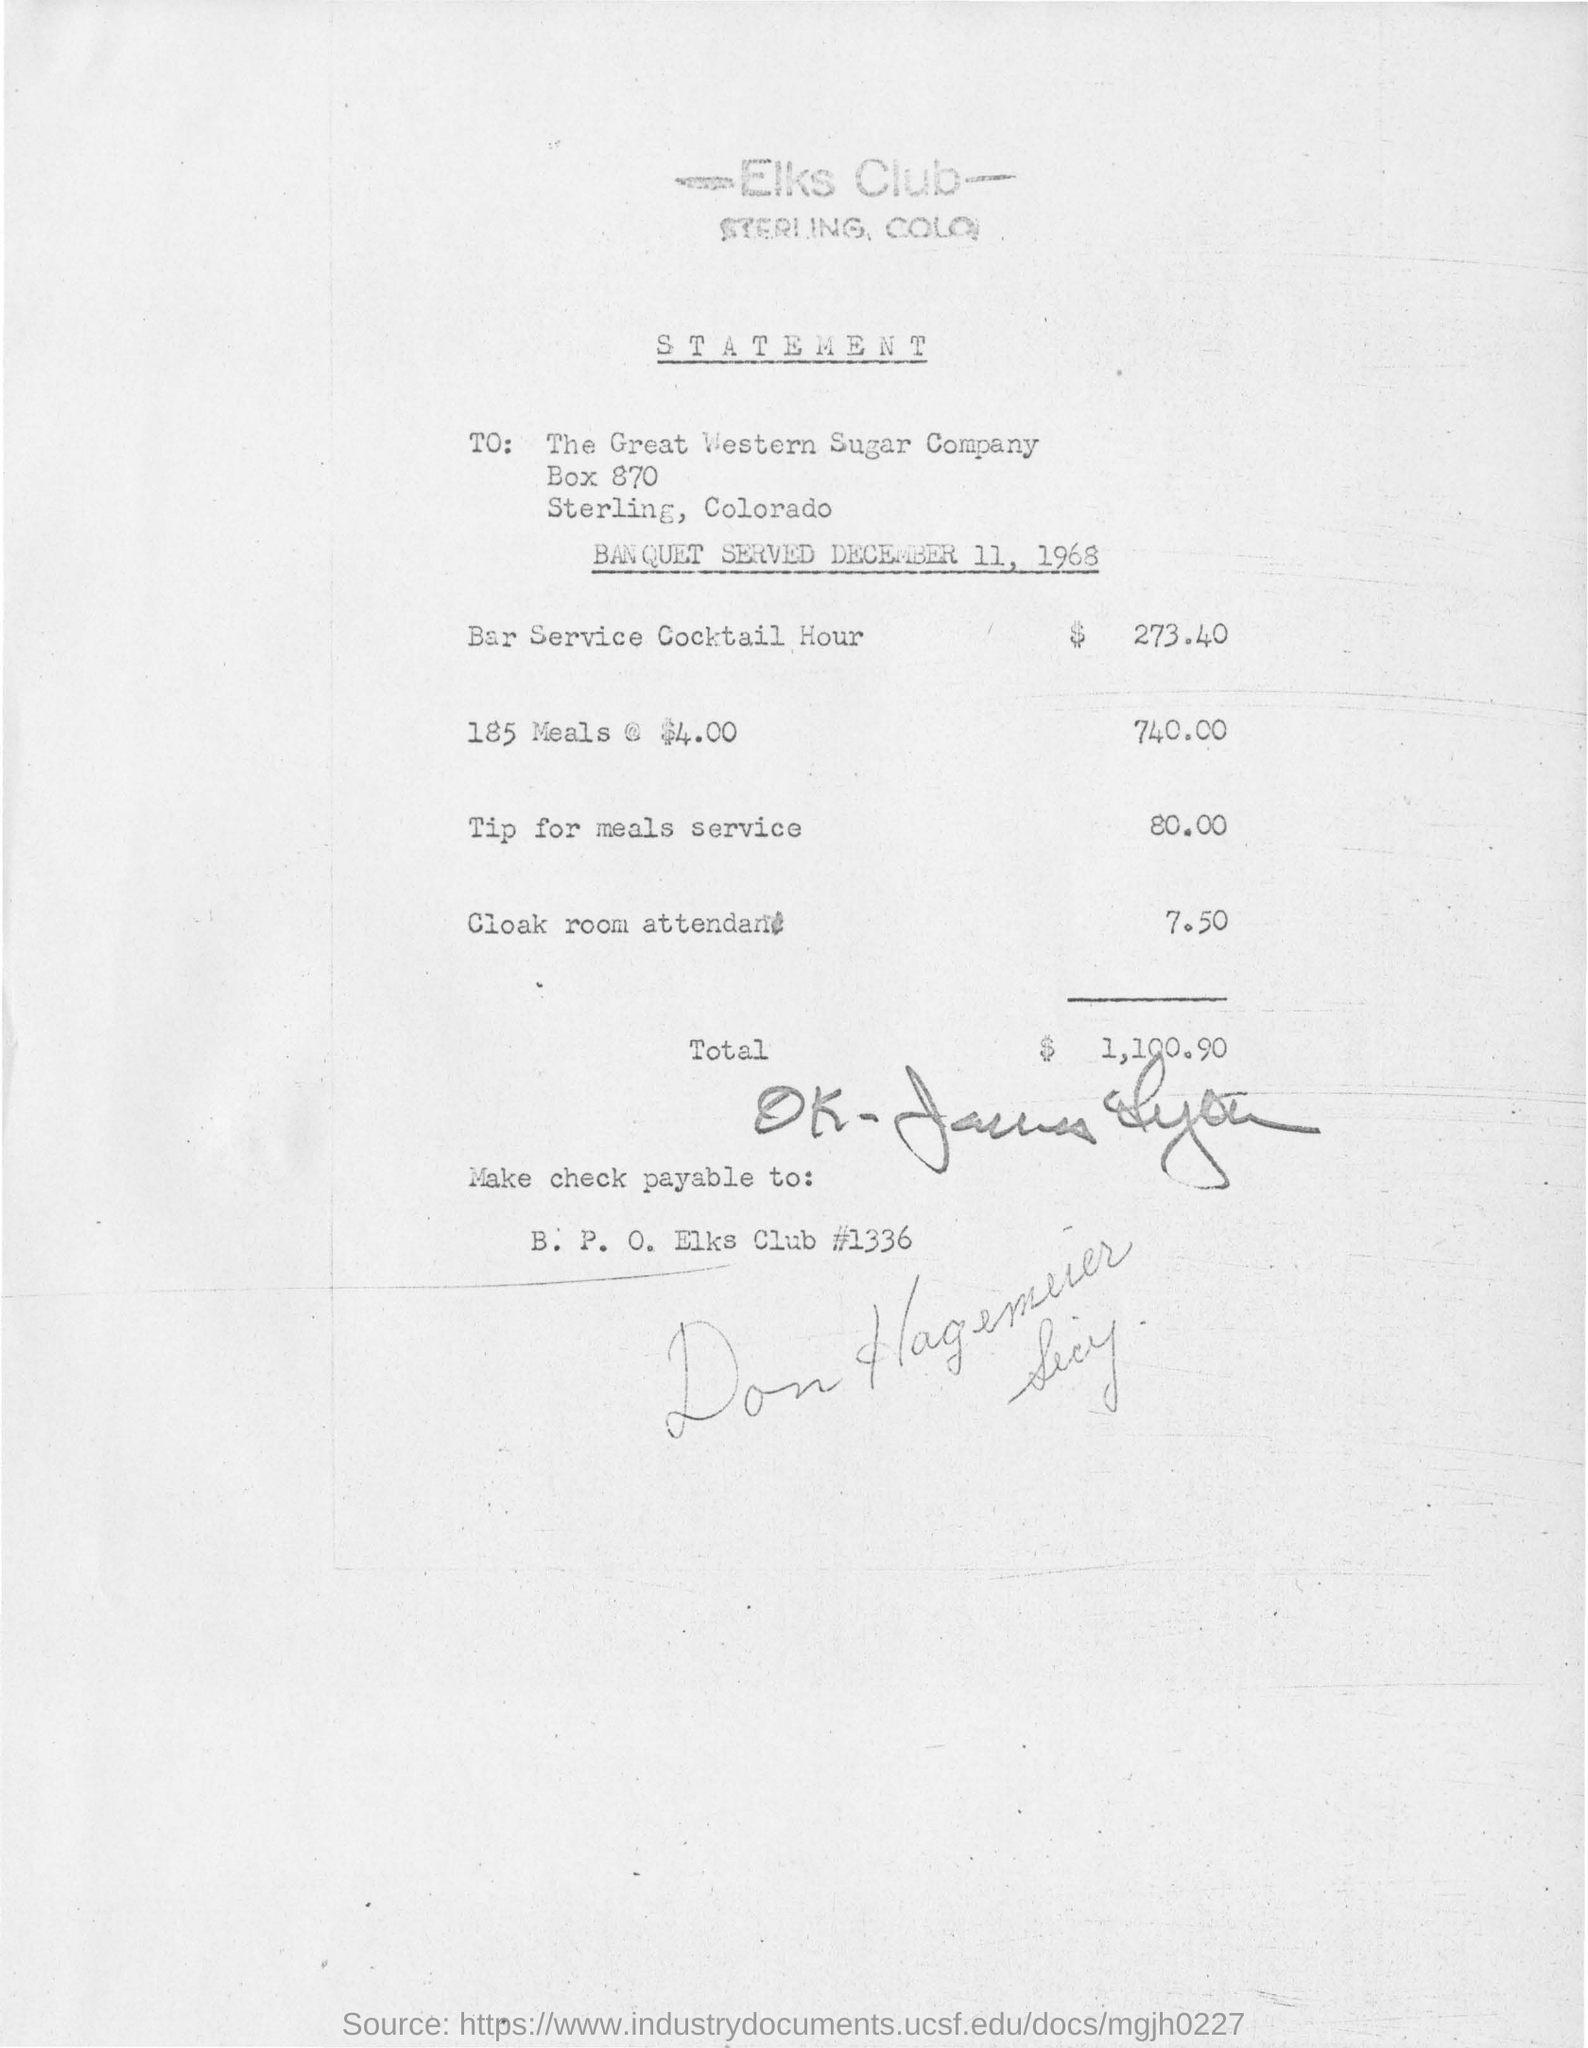Outline some significant characteristics in this image. The amount for the cloak room attendant is $7.50. 